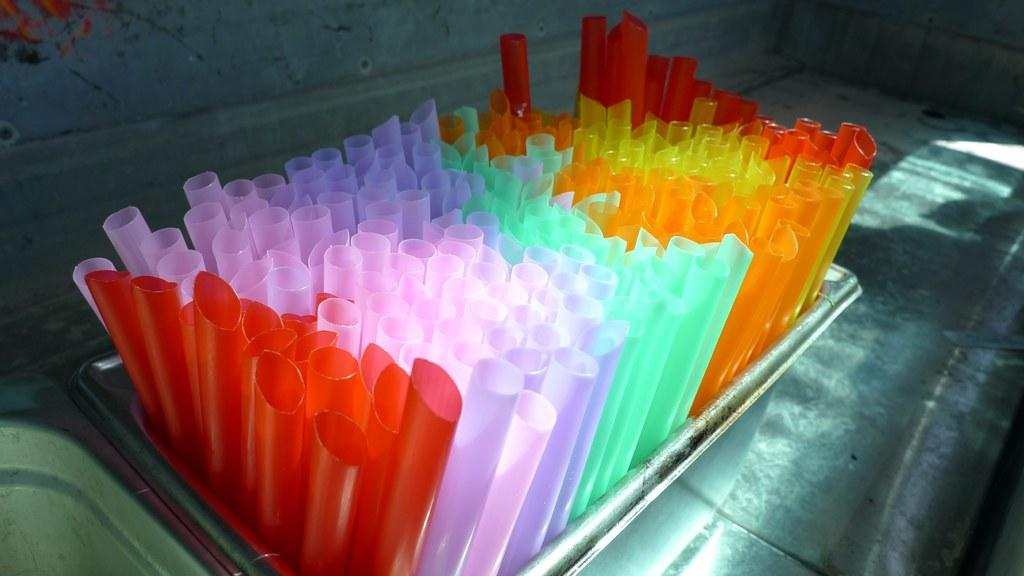What is located in the middle of the image? There is a tray in the middle of the image. What is on the tray? The tray contains different colors of straws. What can be seen in the background of the image? There is a wall visible in the background of the image. What type of instrument is being played in the image? There is no instrument being played in the image; it only features a tray with straws and a wall in the background. 